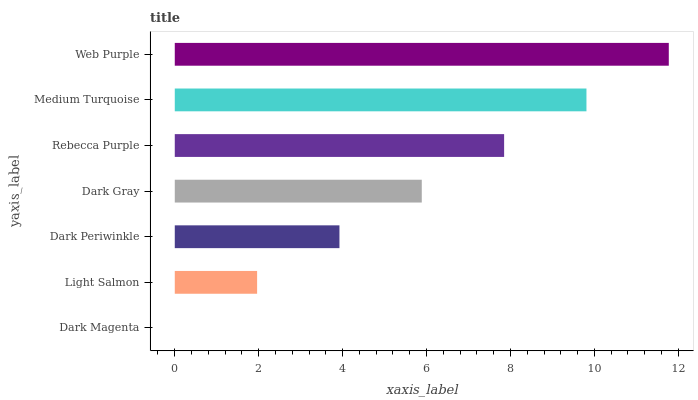Is Dark Magenta the minimum?
Answer yes or no. Yes. Is Web Purple the maximum?
Answer yes or no. Yes. Is Light Salmon the minimum?
Answer yes or no. No. Is Light Salmon the maximum?
Answer yes or no. No. Is Light Salmon greater than Dark Magenta?
Answer yes or no. Yes. Is Dark Magenta less than Light Salmon?
Answer yes or no. Yes. Is Dark Magenta greater than Light Salmon?
Answer yes or no. No. Is Light Salmon less than Dark Magenta?
Answer yes or no. No. Is Dark Gray the high median?
Answer yes or no. Yes. Is Dark Gray the low median?
Answer yes or no. Yes. Is Light Salmon the high median?
Answer yes or no. No. Is Rebecca Purple the low median?
Answer yes or no. No. 